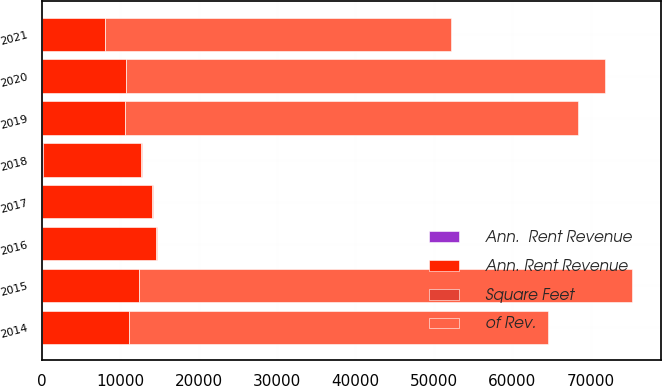Convert chart to OTSL. <chart><loc_0><loc_0><loc_500><loc_500><stacked_bar_chart><ecel><fcel>2014<fcel>2015<fcel>2016<fcel>2017<fcel>2018<fcel>2019<fcel>2020<fcel>2021<nl><fcel>Ann. Rent Revenue<fcel>11158<fcel>12380<fcel>14543<fcel>14009<fcel>12589<fcel>10551<fcel>10751<fcel>7974<nl><fcel>of Rev.<fcel>53397<fcel>62816<fcel>73<fcel>73<fcel>73<fcel>57864<fcel>61021<fcel>44174<nl><fcel>Square Feet<fcel>8<fcel>10<fcel>11<fcel>11<fcel>12<fcel>9<fcel>9<fcel>7<nl><fcel>Ann.  Rent Revenue<fcel>4<fcel>8<fcel>19<fcel>73<fcel>77<fcel>12<fcel>10<fcel>13<nl></chart> 